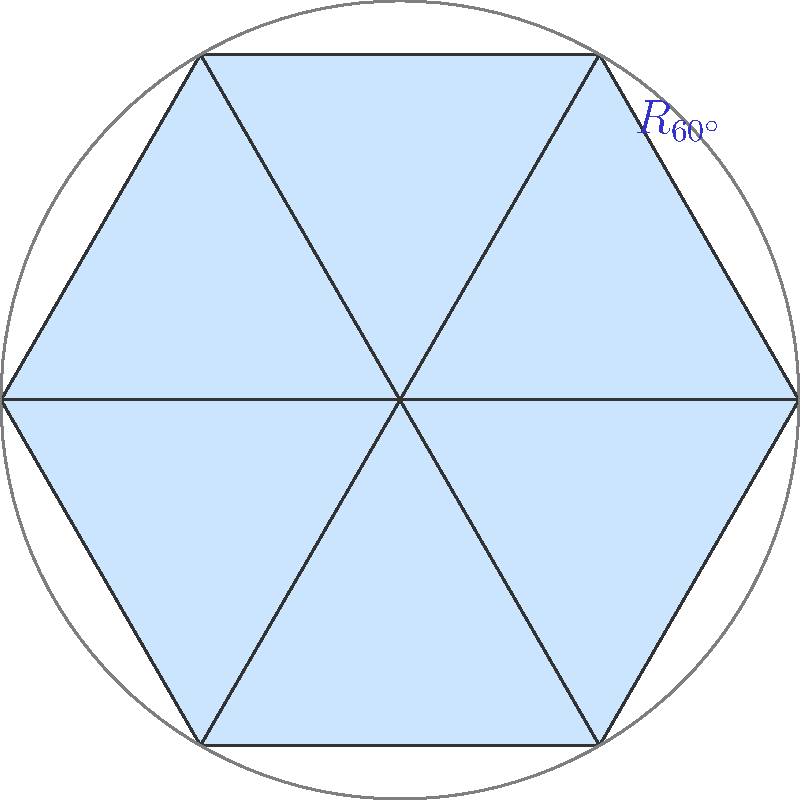For a Beatles-themed event ticket design, you want to create a tessellation pattern using equilateral triangles. The diagram shows a hexagonal arrangement of these triangles. What group transformation is represented by $R_{60^\circ}$ in this tessellation, and how many unique positions can be generated using this transformation? To answer this question, let's break it down step-by-step:

1. The diagram shows a hexagonal arrangement of equilateral triangles.

2. $R_{60^\circ}$ represents a rotation of 60 degrees around the center of the hexagon.

3. This rotation is a group transformation because:
   a) It preserves the shape and size of the triangles (isometry).
   b) It maps the tessellation onto itself (symmetry operation).

4. To determine how many unique positions can be generated:
   a) A full rotation is 360°.
   b) Each application of $R_{60^\circ}$ rotates the pattern by 60°.
   c) We can calculate: $360° ÷ 60° = 6$

5. This means that applying $R_{60^\circ}$ six times will bring the pattern back to its original position.

6. The unique positions are:
   Original, $R_{60^\circ}$, $R_{120^\circ}$, $R_{180^\circ}$, $R_{240^\circ}$, $R_{300^\circ}$

Therefore, $R_{60^\circ}$ represents a 60-degree rotation, and it generates 6 unique positions in this tessellation.
Answer: 60-degree rotation; 6 unique positions 